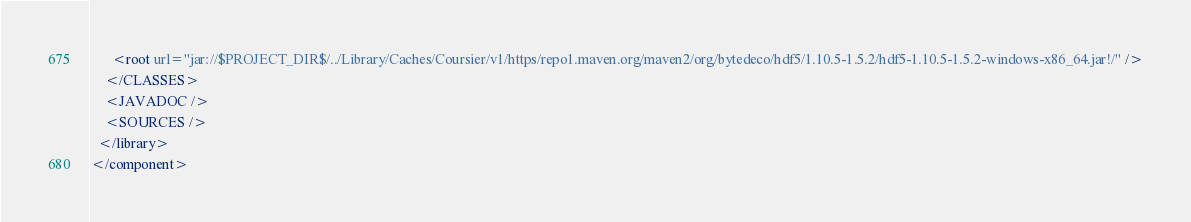Convert code to text. <code><loc_0><loc_0><loc_500><loc_500><_XML_>      <root url="jar://$PROJECT_DIR$/../Library/Caches/Coursier/v1/https/repo1.maven.org/maven2/org/bytedeco/hdf5/1.10.5-1.5.2/hdf5-1.10.5-1.5.2-windows-x86_64.jar!/" />
    </CLASSES>
    <JAVADOC />
    <SOURCES />
  </library>
</component></code> 